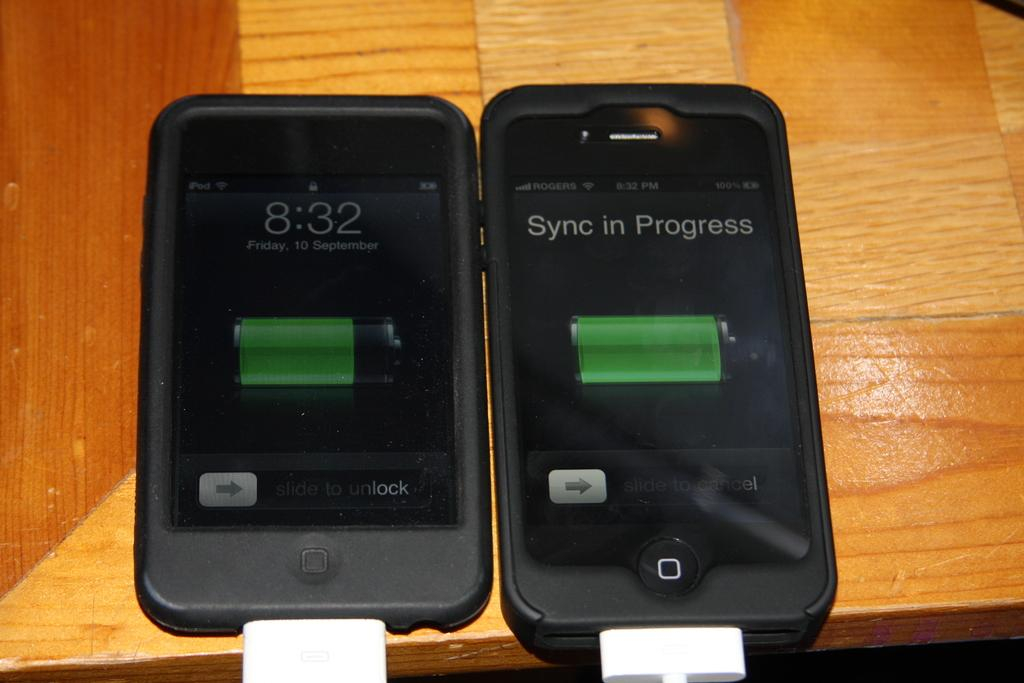<image>
Share a concise interpretation of the image provided. A cell phone screen with the message sync in progress on it. 